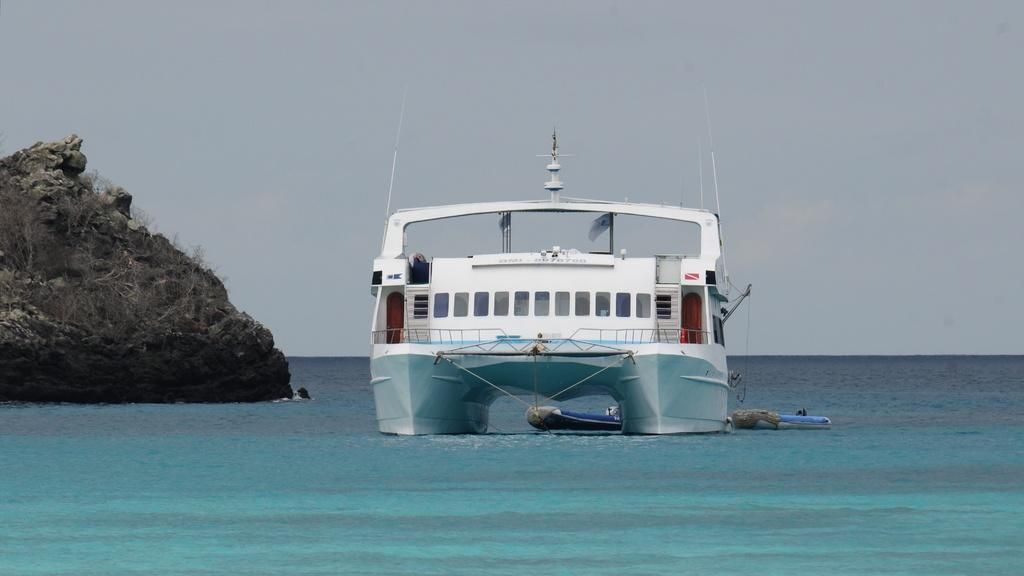What is the main subject in the water in the image? There is a ship in the water. What other watercraft can be seen in the image? There are raft boats in the water. What geological feature is present in the image? There is a rock in the image. What type of vegetation is visible in the image? There are small plants in the image. How would you describe the sky in the image? The sky is cloudy. How does the zebra move on the rock in the image? There is no zebra present in the image, so this question cannot be answered. 